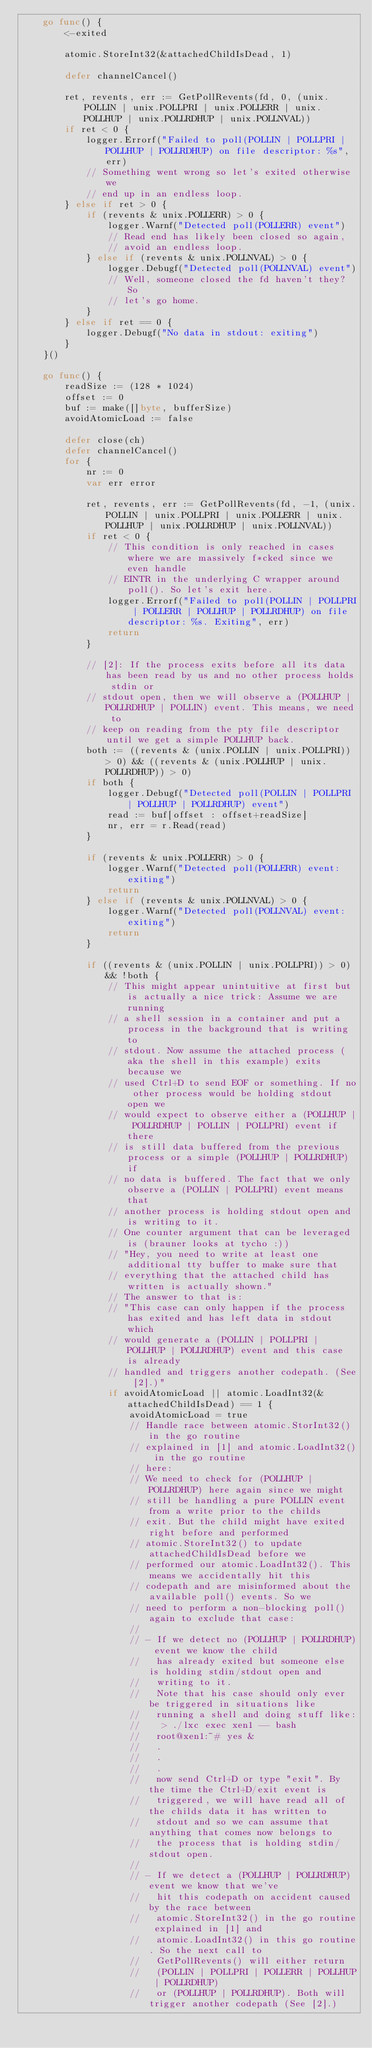<code> <loc_0><loc_0><loc_500><loc_500><_Go_>	go func() {
		<-exited

		atomic.StoreInt32(&attachedChildIsDead, 1)

		defer channelCancel()

		ret, revents, err := GetPollRevents(fd, 0, (unix.POLLIN | unix.POLLPRI | unix.POLLERR | unix.POLLHUP | unix.POLLRDHUP | unix.POLLNVAL))
		if ret < 0 {
			logger.Errorf("Failed to poll(POLLIN | POLLPRI | POLLHUP | POLLRDHUP) on file descriptor: %s", err)
			// Something went wrong so let's exited otherwise we
			// end up in an endless loop.
		} else if ret > 0 {
			if (revents & unix.POLLERR) > 0 {
				logger.Warnf("Detected poll(POLLERR) event")
				// Read end has likely been closed so again,
				// avoid an endless loop.
			} else if (revents & unix.POLLNVAL) > 0 {
				logger.Debugf("Detected poll(POLLNVAL) event")
				// Well, someone closed the fd haven't they? So
				// let's go home.
			}
		} else if ret == 0 {
			logger.Debugf("No data in stdout: exiting")
		}
	}()

	go func() {
		readSize := (128 * 1024)
		offset := 0
		buf := make([]byte, bufferSize)
		avoidAtomicLoad := false

		defer close(ch)
		defer channelCancel()
		for {
			nr := 0
			var err error

			ret, revents, err := GetPollRevents(fd, -1, (unix.POLLIN | unix.POLLPRI | unix.POLLERR | unix.POLLHUP | unix.POLLRDHUP | unix.POLLNVAL))
			if ret < 0 {
				// This condition is only reached in cases where we are massively f*cked since we even handle
				// EINTR in the underlying C wrapper around poll(). So let's exit here.
				logger.Errorf("Failed to poll(POLLIN | POLLPRI | POLLERR | POLLHUP | POLLRDHUP) on file descriptor: %s. Exiting", err)
				return
			}

			// [2]: If the process exits before all its data has been read by us and no other process holds stdin or
			// stdout open, then we will observe a (POLLHUP | POLLRDHUP | POLLIN) event. This means, we need to
			// keep on reading from the pty file descriptor until we get a simple POLLHUP back.
			both := ((revents & (unix.POLLIN | unix.POLLPRI)) > 0) && ((revents & (unix.POLLHUP | unix.POLLRDHUP)) > 0)
			if both {
				logger.Debugf("Detected poll(POLLIN | POLLPRI | POLLHUP | POLLRDHUP) event")
				read := buf[offset : offset+readSize]
				nr, err = r.Read(read)
			}

			if (revents & unix.POLLERR) > 0 {
				logger.Warnf("Detected poll(POLLERR) event: exiting")
				return
			} else if (revents & unix.POLLNVAL) > 0 {
				logger.Warnf("Detected poll(POLLNVAL) event: exiting")
				return
			}

			if ((revents & (unix.POLLIN | unix.POLLPRI)) > 0) && !both {
				// This might appear unintuitive at first but is actually a nice trick: Assume we are running
				// a shell session in a container and put a process in the background that is writing to
				// stdout. Now assume the attached process (aka the shell in this example) exits because we
				// used Ctrl+D to send EOF or something. If no other process would be holding stdout open we
				// would expect to observe either a (POLLHUP | POLLRDHUP | POLLIN | POLLPRI) event if there
				// is still data buffered from the previous process or a simple (POLLHUP | POLLRDHUP) if
				// no data is buffered. The fact that we only observe a (POLLIN | POLLPRI) event means that
				// another process is holding stdout open and is writing to it.
				// One counter argument that can be leveraged is (brauner looks at tycho :))
				// "Hey, you need to write at least one additional tty buffer to make sure that
				// everything that the attached child has written is actually shown."
				// The answer to that is:
				// "This case can only happen if the process has exited and has left data in stdout which
				// would generate a (POLLIN | POLLPRI | POLLHUP | POLLRDHUP) event and this case is already
				// handled and triggers another codepath. (See [2].)"
				if avoidAtomicLoad || atomic.LoadInt32(&attachedChildIsDead) == 1 {
					avoidAtomicLoad = true
					// Handle race between atomic.StorInt32() in the go routine
					// explained in [1] and atomic.LoadInt32() in the go routine
					// here:
					// We need to check for (POLLHUP | POLLRDHUP) here again since we might
					// still be handling a pure POLLIN event from a write prior to the childs
					// exit. But the child might have exited right before and performed
					// atomic.StoreInt32() to update attachedChildIsDead before we
					// performed our atomic.LoadInt32(). This means we accidentally hit this
					// codepath and are misinformed about the available poll() events. So we
					// need to perform a non-blocking poll() again to exclude that case:
					//
					// - If we detect no (POLLHUP | POLLRDHUP) event we know the child
					//   has already exited but someone else is holding stdin/stdout open and
					//   writing to it.
					//   Note that his case should only ever be triggered in situations like
					//   running a shell and doing stuff like:
					//    > ./lxc exec xen1 -- bash
					//   root@xen1:~# yes &
					//   .
					//   .
					//   .
					//   now send Ctrl+D or type "exit". By the time the Ctrl+D/exit event is
					//   triggered, we will have read all of the childs data it has written to
					//   stdout and so we can assume that anything that comes now belongs to
					//   the process that is holding stdin/stdout open.
					//
					// - If we detect a (POLLHUP | POLLRDHUP) event we know that we've
					//   hit this codepath on accident caused by the race between
					//   atomic.StoreInt32() in the go routine explained in [1] and
					//   atomic.LoadInt32() in this go routine. So the next call to
					//   GetPollRevents() will either return
					//   (POLLIN | POLLPRI | POLLERR | POLLHUP | POLLRDHUP)
					//   or (POLLHUP | POLLRDHUP). Both will trigger another codepath (See [2].)</code> 